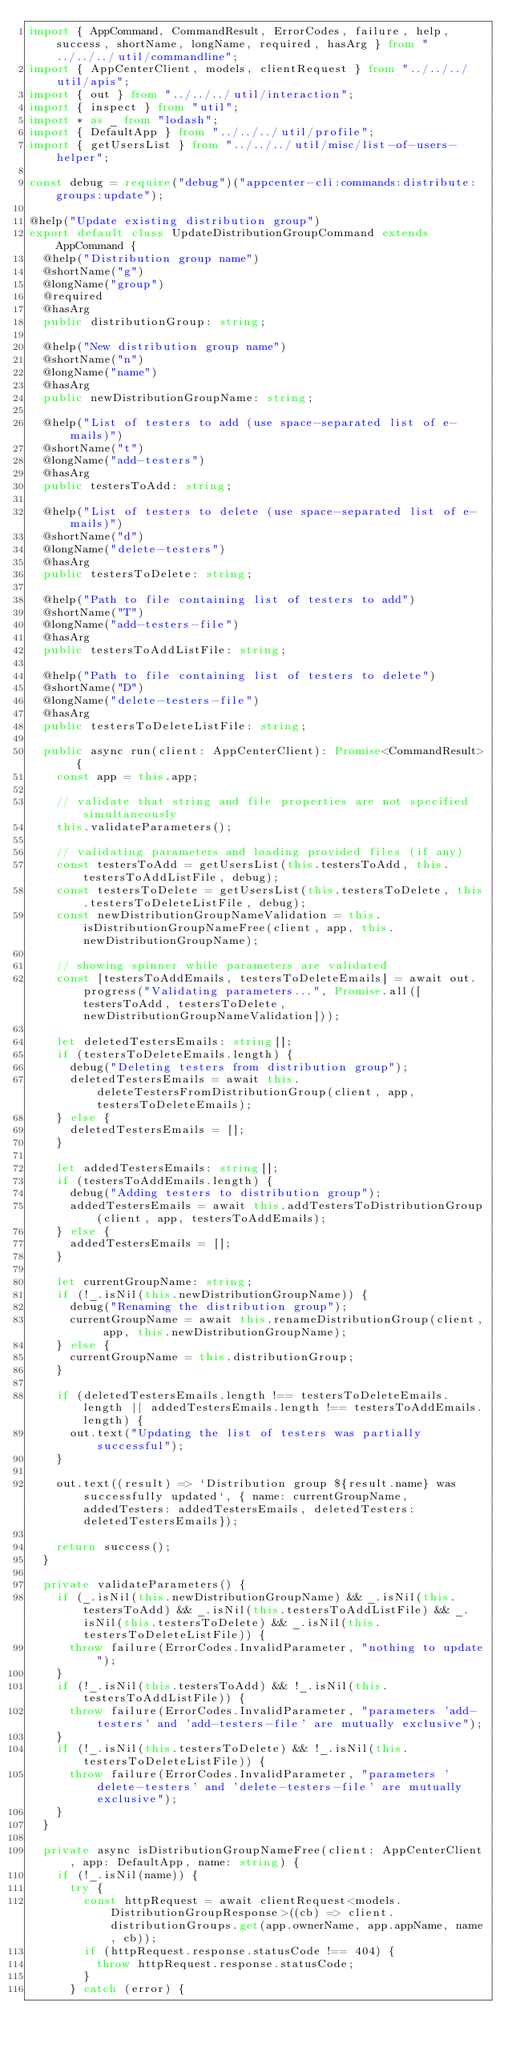<code> <loc_0><loc_0><loc_500><loc_500><_TypeScript_>import { AppCommand, CommandResult, ErrorCodes, failure, help, success, shortName, longName, required, hasArg } from "../../../util/commandline";
import { AppCenterClient, models, clientRequest } from "../../../util/apis";
import { out } from "../../../util/interaction";
import { inspect } from "util";
import * as _ from "lodash";
import { DefaultApp } from "../../../util/profile";
import { getUsersList } from "../../../util/misc/list-of-users-helper";

const debug = require("debug")("appcenter-cli:commands:distribute:groups:update");

@help("Update existing distribution group")
export default class UpdateDistributionGroupCommand extends AppCommand {
  @help("Distribution group name")
  @shortName("g")
  @longName("group")
  @required
  @hasArg
  public distributionGroup: string;

  @help("New distribution group name")
  @shortName("n")
  @longName("name")
  @hasArg
  public newDistributionGroupName: string;

  @help("List of testers to add (use space-separated list of e-mails)")
  @shortName("t")
  @longName("add-testers")
  @hasArg
  public testersToAdd: string;

  @help("List of testers to delete (use space-separated list of e-mails)")
  @shortName("d")
  @longName("delete-testers")
  @hasArg
  public testersToDelete: string;

  @help("Path to file containing list of testers to add")
  @shortName("T")
  @longName("add-testers-file")
  @hasArg
  public testersToAddListFile: string;

  @help("Path to file containing list of testers to delete")
  @shortName("D")
  @longName("delete-testers-file")
  @hasArg
  public testersToDeleteListFile: string;

  public async run(client: AppCenterClient): Promise<CommandResult> {
    const app = this.app;

    // validate that string and file properties are not specified simultaneously
    this.validateParameters();

    // validating parameters and loading provided files (if any)
    const testersToAdd = getUsersList(this.testersToAdd, this.testersToAddListFile, debug);
    const testersToDelete = getUsersList(this.testersToDelete, this.testersToDeleteListFile, debug);
    const newDistributionGroupNameValidation = this.isDistributionGroupNameFree(client, app, this.newDistributionGroupName);

    // showing spinner while parameters are validated
    const [testersToAddEmails, testersToDeleteEmails] = await out.progress("Validating parameters...", Promise.all([testersToAdd, testersToDelete, newDistributionGroupNameValidation]));

    let deletedTestersEmails: string[];
    if (testersToDeleteEmails.length) {
      debug("Deleting testers from distribution group");
      deletedTestersEmails = await this.deleteTestersFromDistributionGroup(client, app, testersToDeleteEmails);
    } else {
      deletedTestersEmails = [];
    }

    let addedTestersEmails: string[];
    if (testersToAddEmails.length) {
      debug("Adding testers to distribution group");
      addedTestersEmails = await this.addTestersToDistributionGroup(client, app, testersToAddEmails);
    } else {
      addedTestersEmails = [];
    }

    let currentGroupName: string;
    if (!_.isNil(this.newDistributionGroupName)) {
      debug("Renaming the distribution group");
      currentGroupName = await this.renameDistributionGroup(client, app, this.newDistributionGroupName);
    } else {
      currentGroupName = this.distributionGroup;
    }

    if (deletedTestersEmails.length !== testersToDeleteEmails.length || addedTestersEmails.length !== testersToAddEmails.length) {
      out.text("Updating the list of testers was partially successful");
    }

    out.text((result) => `Distribution group ${result.name} was successfully updated`, { name: currentGroupName, addedTesters: addedTestersEmails, deletedTesters: deletedTestersEmails});

    return success();
  }

  private validateParameters() {
    if (_.isNil(this.newDistributionGroupName) && _.isNil(this.testersToAdd) && _.isNil(this.testersToAddListFile) && _.isNil(this.testersToDelete) && _.isNil(this.testersToDeleteListFile)) {
      throw failure(ErrorCodes.InvalidParameter, "nothing to update");
    }
    if (!_.isNil(this.testersToAdd) && !_.isNil(this.testersToAddListFile)) {
      throw failure(ErrorCodes.InvalidParameter, "parameters 'add-testers' and 'add-testers-file' are mutually exclusive");
    }
    if (!_.isNil(this.testersToDelete) && !_.isNil(this.testersToDeleteListFile)) {
      throw failure(ErrorCodes.InvalidParameter, "parameters 'delete-testers' and 'delete-testers-file' are mutually exclusive");
    }
  }

  private async isDistributionGroupNameFree(client: AppCenterClient, app: DefaultApp, name: string) {
    if (!_.isNil(name)) {
      try {
        const httpRequest = await clientRequest<models.DistributionGroupResponse>((cb) => client.distributionGroups.get(app.ownerName, app.appName, name, cb));
        if (httpRequest.response.statusCode !== 404) {
          throw httpRequest.response.statusCode;
        }
      } catch (error) {</code> 